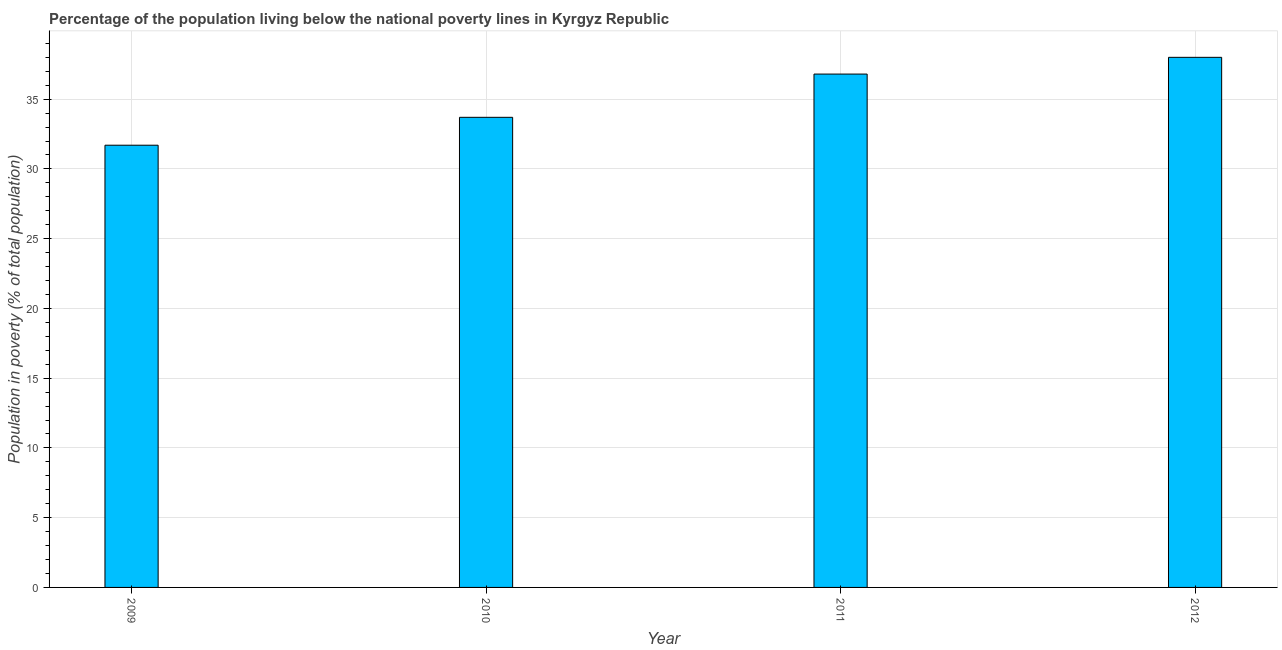Does the graph contain grids?
Provide a succinct answer. Yes. What is the title of the graph?
Your answer should be very brief. Percentage of the population living below the national poverty lines in Kyrgyz Republic. What is the label or title of the X-axis?
Your answer should be very brief. Year. What is the label or title of the Y-axis?
Your answer should be very brief. Population in poverty (% of total population). What is the percentage of population living below poverty line in 2010?
Provide a short and direct response. 33.7. Across all years, what is the minimum percentage of population living below poverty line?
Your answer should be very brief. 31.7. What is the sum of the percentage of population living below poverty line?
Offer a very short reply. 140.2. What is the difference between the percentage of population living below poverty line in 2009 and 2012?
Your answer should be compact. -6.3. What is the average percentage of population living below poverty line per year?
Ensure brevity in your answer.  35.05. What is the median percentage of population living below poverty line?
Ensure brevity in your answer.  35.25. What is the ratio of the percentage of population living below poverty line in 2011 to that in 2012?
Provide a short and direct response. 0.97. Is the percentage of population living below poverty line in 2009 less than that in 2011?
Offer a very short reply. Yes. Is the difference between the percentage of population living below poverty line in 2010 and 2011 greater than the difference between any two years?
Keep it short and to the point. No. In how many years, is the percentage of population living below poverty line greater than the average percentage of population living below poverty line taken over all years?
Give a very brief answer. 2. Are all the bars in the graph horizontal?
Provide a short and direct response. No. Are the values on the major ticks of Y-axis written in scientific E-notation?
Give a very brief answer. No. What is the Population in poverty (% of total population) in 2009?
Your answer should be very brief. 31.7. What is the Population in poverty (% of total population) of 2010?
Provide a succinct answer. 33.7. What is the Population in poverty (% of total population) in 2011?
Provide a succinct answer. 36.8. What is the Population in poverty (% of total population) in 2012?
Offer a very short reply. 38. What is the difference between the Population in poverty (% of total population) in 2009 and 2012?
Provide a succinct answer. -6.3. What is the difference between the Population in poverty (% of total population) in 2010 and 2011?
Offer a very short reply. -3.1. What is the difference between the Population in poverty (% of total population) in 2010 and 2012?
Provide a succinct answer. -4.3. What is the ratio of the Population in poverty (% of total population) in 2009 to that in 2010?
Your answer should be compact. 0.94. What is the ratio of the Population in poverty (% of total population) in 2009 to that in 2011?
Offer a very short reply. 0.86. What is the ratio of the Population in poverty (% of total population) in 2009 to that in 2012?
Offer a very short reply. 0.83. What is the ratio of the Population in poverty (% of total population) in 2010 to that in 2011?
Make the answer very short. 0.92. What is the ratio of the Population in poverty (% of total population) in 2010 to that in 2012?
Provide a short and direct response. 0.89. What is the ratio of the Population in poverty (% of total population) in 2011 to that in 2012?
Keep it short and to the point. 0.97. 